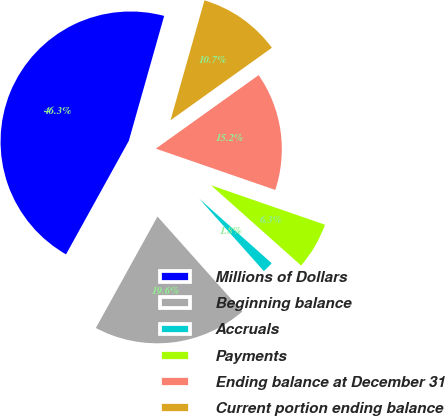Convert chart to OTSL. <chart><loc_0><loc_0><loc_500><loc_500><pie_chart><fcel>Millions of Dollars<fcel>Beginning balance<fcel>Accruals<fcel>Payments<fcel>Ending balance at December 31<fcel>Current portion ending balance<nl><fcel>46.35%<fcel>19.64%<fcel>1.82%<fcel>6.28%<fcel>15.18%<fcel>10.73%<nl></chart> 